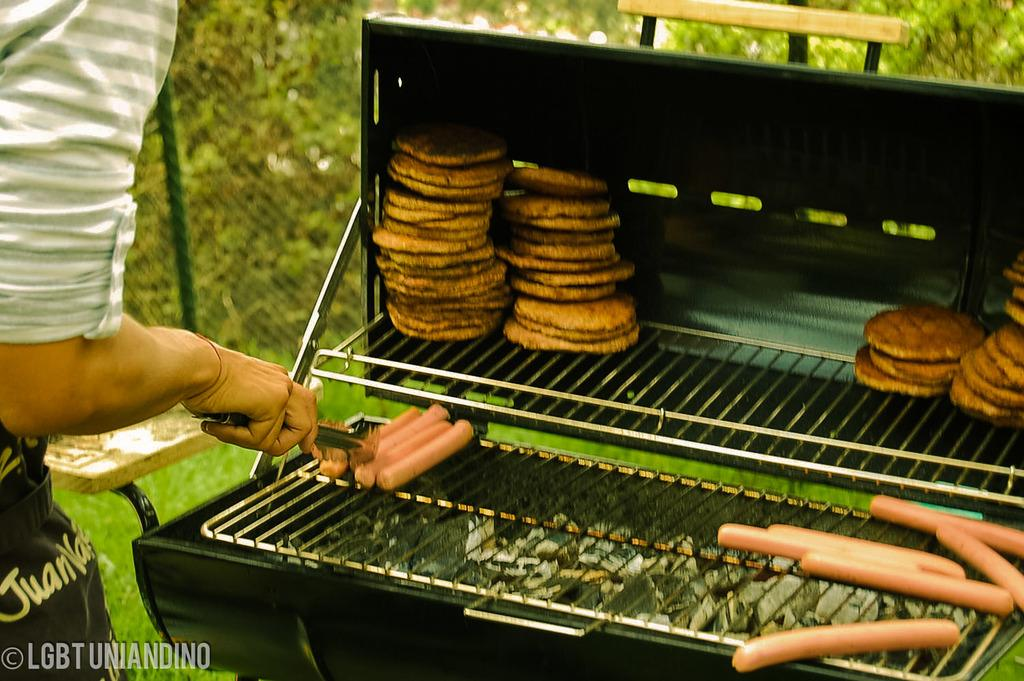<image>
Relay a brief, clear account of the picture shown. A person is grilling in a photograph taken by LGBTUNIANDINO 